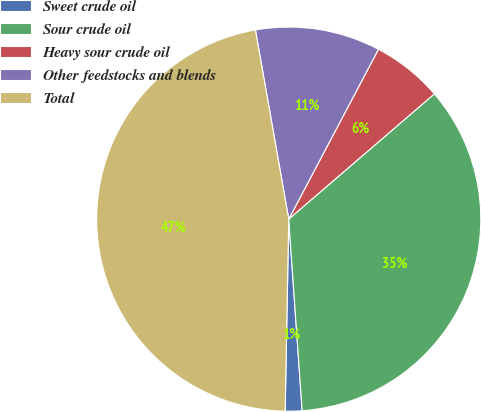Convert chart. <chart><loc_0><loc_0><loc_500><loc_500><pie_chart><fcel>Sweet crude oil<fcel>Sour crude oil<fcel>Heavy sour crude oil<fcel>Other feedstocks and blends<fcel>Total<nl><fcel>1.41%<fcel>35.19%<fcel>5.96%<fcel>10.51%<fcel>46.93%<nl></chart> 